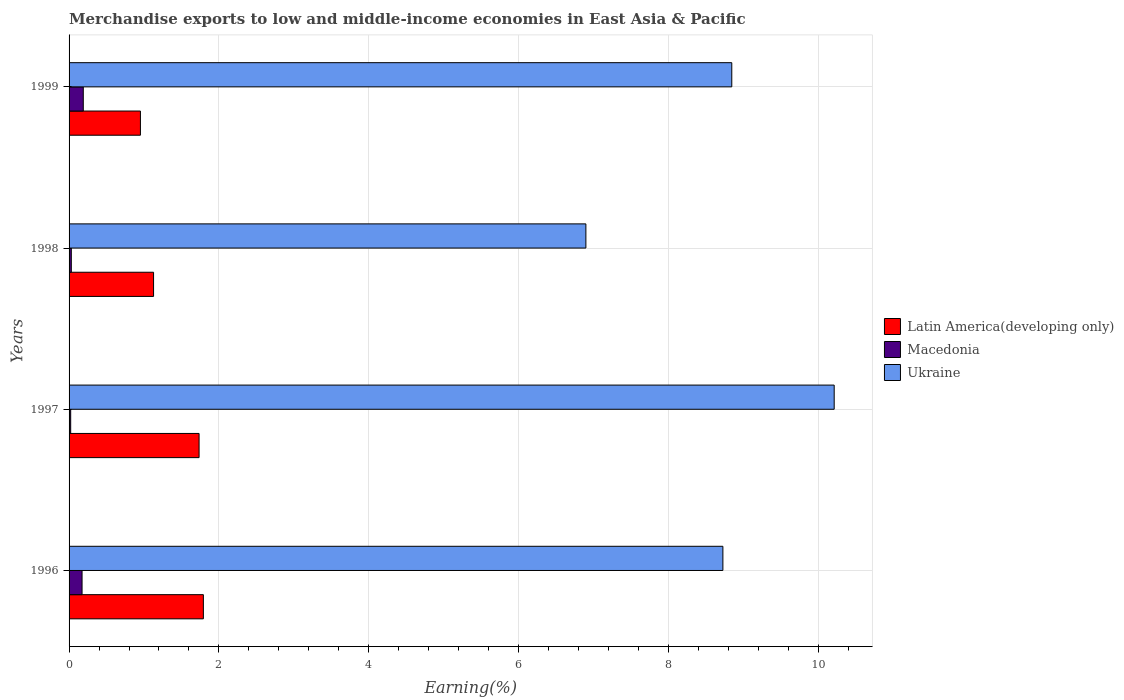Are the number of bars on each tick of the Y-axis equal?
Ensure brevity in your answer.  Yes. How many bars are there on the 4th tick from the top?
Ensure brevity in your answer.  3. How many bars are there on the 1st tick from the bottom?
Provide a succinct answer. 3. In how many cases, is the number of bars for a given year not equal to the number of legend labels?
Provide a short and direct response. 0. What is the percentage of amount earned from merchandise exports in Latin America(developing only) in 1996?
Provide a short and direct response. 1.79. Across all years, what is the maximum percentage of amount earned from merchandise exports in Latin America(developing only)?
Your answer should be very brief. 1.79. Across all years, what is the minimum percentage of amount earned from merchandise exports in Ukraine?
Provide a short and direct response. 6.9. What is the total percentage of amount earned from merchandise exports in Ukraine in the graph?
Keep it short and to the point. 34.69. What is the difference between the percentage of amount earned from merchandise exports in Macedonia in 1997 and that in 1998?
Keep it short and to the point. -0.01. What is the difference between the percentage of amount earned from merchandise exports in Macedonia in 1997 and the percentage of amount earned from merchandise exports in Ukraine in 1999?
Ensure brevity in your answer.  -8.82. What is the average percentage of amount earned from merchandise exports in Latin America(developing only) per year?
Your response must be concise. 1.4. In the year 1997, what is the difference between the percentage of amount earned from merchandise exports in Ukraine and percentage of amount earned from merchandise exports in Latin America(developing only)?
Your response must be concise. 8.48. What is the ratio of the percentage of amount earned from merchandise exports in Latin America(developing only) in 1996 to that in 1997?
Ensure brevity in your answer.  1.03. Is the percentage of amount earned from merchandise exports in Macedonia in 1996 less than that in 1997?
Offer a very short reply. No. What is the difference between the highest and the second highest percentage of amount earned from merchandise exports in Ukraine?
Provide a short and direct response. 1.37. What is the difference between the highest and the lowest percentage of amount earned from merchandise exports in Macedonia?
Make the answer very short. 0.17. Is the sum of the percentage of amount earned from merchandise exports in Macedonia in 1997 and 1998 greater than the maximum percentage of amount earned from merchandise exports in Ukraine across all years?
Keep it short and to the point. No. What does the 2nd bar from the top in 1998 represents?
Provide a succinct answer. Macedonia. What does the 1st bar from the bottom in 1998 represents?
Your answer should be very brief. Latin America(developing only). Is it the case that in every year, the sum of the percentage of amount earned from merchandise exports in Macedonia and percentage of amount earned from merchandise exports in Latin America(developing only) is greater than the percentage of amount earned from merchandise exports in Ukraine?
Ensure brevity in your answer.  No. How many bars are there?
Give a very brief answer. 12. What is the difference between two consecutive major ticks on the X-axis?
Your answer should be very brief. 2. Are the values on the major ticks of X-axis written in scientific E-notation?
Offer a terse response. No. Does the graph contain any zero values?
Provide a succinct answer. No. Where does the legend appear in the graph?
Offer a terse response. Center right. How many legend labels are there?
Provide a succinct answer. 3. How are the legend labels stacked?
Make the answer very short. Vertical. What is the title of the graph?
Provide a short and direct response. Merchandise exports to low and middle-income economies in East Asia & Pacific. Does "Togo" appear as one of the legend labels in the graph?
Provide a short and direct response. No. What is the label or title of the X-axis?
Your response must be concise. Earning(%). What is the Earning(%) in Latin America(developing only) in 1996?
Give a very brief answer. 1.79. What is the Earning(%) of Macedonia in 1996?
Offer a terse response. 0.17. What is the Earning(%) in Ukraine in 1996?
Your response must be concise. 8.73. What is the Earning(%) in Latin America(developing only) in 1997?
Keep it short and to the point. 1.74. What is the Earning(%) of Macedonia in 1997?
Provide a short and direct response. 0.02. What is the Earning(%) of Ukraine in 1997?
Keep it short and to the point. 10.21. What is the Earning(%) of Latin America(developing only) in 1998?
Give a very brief answer. 1.13. What is the Earning(%) of Macedonia in 1998?
Ensure brevity in your answer.  0.03. What is the Earning(%) in Ukraine in 1998?
Your response must be concise. 6.9. What is the Earning(%) of Latin America(developing only) in 1999?
Offer a very short reply. 0.95. What is the Earning(%) of Macedonia in 1999?
Give a very brief answer. 0.19. What is the Earning(%) of Ukraine in 1999?
Make the answer very short. 8.85. Across all years, what is the maximum Earning(%) in Latin America(developing only)?
Provide a succinct answer. 1.79. Across all years, what is the maximum Earning(%) of Macedonia?
Ensure brevity in your answer.  0.19. Across all years, what is the maximum Earning(%) in Ukraine?
Provide a short and direct response. 10.21. Across all years, what is the minimum Earning(%) in Latin America(developing only)?
Offer a very short reply. 0.95. Across all years, what is the minimum Earning(%) of Macedonia?
Ensure brevity in your answer.  0.02. Across all years, what is the minimum Earning(%) of Ukraine?
Make the answer very short. 6.9. What is the total Earning(%) in Latin America(developing only) in the graph?
Give a very brief answer. 5.61. What is the total Earning(%) of Macedonia in the graph?
Your answer should be compact. 0.41. What is the total Earning(%) of Ukraine in the graph?
Provide a short and direct response. 34.69. What is the difference between the Earning(%) of Latin America(developing only) in 1996 and that in 1997?
Your response must be concise. 0.06. What is the difference between the Earning(%) of Macedonia in 1996 and that in 1997?
Your answer should be very brief. 0.15. What is the difference between the Earning(%) in Ukraine in 1996 and that in 1997?
Provide a succinct answer. -1.49. What is the difference between the Earning(%) of Latin America(developing only) in 1996 and that in 1998?
Provide a succinct answer. 0.66. What is the difference between the Earning(%) in Macedonia in 1996 and that in 1998?
Give a very brief answer. 0.14. What is the difference between the Earning(%) of Ukraine in 1996 and that in 1998?
Make the answer very short. 1.83. What is the difference between the Earning(%) of Latin America(developing only) in 1996 and that in 1999?
Your answer should be very brief. 0.84. What is the difference between the Earning(%) of Macedonia in 1996 and that in 1999?
Provide a short and direct response. -0.02. What is the difference between the Earning(%) of Ukraine in 1996 and that in 1999?
Your answer should be compact. -0.12. What is the difference between the Earning(%) in Latin America(developing only) in 1997 and that in 1998?
Offer a terse response. 0.61. What is the difference between the Earning(%) in Macedonia in 1997 and that in 1998?
Provide a succinct answer. -0.01. What is the difference between the Earning(%) in Ukraine in 1997 and that in 1998?
Provide a short and direct response. 3.31. What is the difference between the Earning(%) of Latin America(developing only) in 1997 and that in 1999?
Provide a short and direct response. 0.78. What is the difference between the Earning(%) of Macedonia in 1997 and that in 1999?
Provide a short and direct response. -0.17. What is the difference between the Earning(%) of Ukraine in 1997 and that in 1999?
Provide a succinct answer. 1.37. What is the difference between the Earning(%) of Latin America(developing only) in 1998 and that in 1999?
Your response must be concise. 0.18. What is the difference between the Earning(%) in Macedonia in 1998 and that in 1999?
Give a very brief answer. -0.16. What is the difference between the Earning(%) in Ukraine in 1998 and that in 1999?
Your answer should be very brief. -1.95. What is the difference between the Earning(%) of Latin America(developing only) in 1996 and the Earning(%) of Macedonia in 1997?
Your response must be concise. 1.77. What is the difference between the Earning(%) of Latin America(developing only) in 1996 and the Earning(%) of Ukraine in 1997?
Your answer should be compact. -8.42. What is the difference between the Earning(%) in Macedonia in 1996 and the Earning(%) in Ukraine in 1997?
Your response must be concise. -10.04. What is the difference between the Earning(%) in Latin America(developing only) in 1996 and the Earning(%) in Macedonia in 1998?
Offer a terse response. 1.76. What is the difference between the Earning(%) in Latin America(developing only) in 1996 and the Earning(%) in Ukraine in 1998?
Provide a succinct answer. -5.11. What is the difference between the Earning(%) of Macedonia in 1996 and the Earning(%) of Ukraine in 1998?
Offer a terse response. -6.73. What is the difference between the Earning(%) of Latin America(developing only) in 1996 and the Earning(%) of Macedonia in 1999?
Offer a very short reply. 1.6. What is the difference between the Earning(%) of Latin America(developing only) in 1996 and the Earning(%) of Ukraine in 1999?
Ensure brevity in your answer.  -7.05. What is the difference between the Earning(%) in Macedonia in 1996 and the Earning(%) in Ukraine in 1999?
Offer a terse response. -8.67. What is the difference between the Earning(%) of Latin America(developing only) in 1997 and the Earning(%) of Macedonia in 1998?
Give a very brief answer. 1.71. What is the difference between the Earning(%) in Latin America(developing only) in 1997 and the Earning(%) in Ukraine in 1998?
Give a very brief answer. -5.16. What is the difference between the Earning(%) of Macedonia in 1997 and the Earning(%) of Ukraine in 1998?
Keep it short and to the point. -6.88. What is the difference between the Earning(%) in Latin America(developing only) in 1997 and the Earning(%) in Macedonia in 1999?
Ensure brevity in your answer.  1.55. What is the difference between the Earning(%) in Latin America(developing only) in 1997 and the Earning(%) in Ukraine in 1999?
Your response must be concise. -7.11. What is the difference between the Earning(%) of Macedonia in 1997 and the Earning(%) of Ukraine in 1999?
Keep it short and to the point. -8.82. What is the difference between the Earning(%) in Latin America(developing only) in 1998 and the Earning(%) in Macedonia in 1999?
Provide a succinct answer. 0.94. What is the difference between the Earning(%) in Latin America(developing only) in 1998 and the Earning(%) in Ukraine in 1999?
Provide a succinct answer. -7.72. What is the difference between the Earning(%) in Macedonia in 1998 and the Earning(%) in Ukraine in 1999?
Offer a terse response. -8.82. What is the average Earning(%) of Latin America(developing only) per year?
Your answer should be compact. 1.4. What is the average Earning(%) in Macedonia per year?
Keep it short and to the point. 0.1. What is the average Earning(%) in Ukraine per year?
Provide a succinct answer. 8.67. In the year 1996, what is the difference between the Earning(%) of Latin America(developing only) and Earning(%) of Macedonia?
Provide a succinct answer. 1.62. In the year 1996, what is the difference between the Earning(%) in Latin America(developing only) and Earning(%) in Ukraine?
Your answer should be very brief. -6.93. In the year 1996, what is the difference between the Earning(%) of Macedonia and Earning(%) of Ukraine?
Make the answer very short. -8.55. In the year 1997, what is the difference between the Earning(%) of Latin America(developing only) and Earning(%) of Macedonia?
Your answer should be very brief. 1.71. In the year 1997, what is the difference between the Earning(%) of Latin America(developing only) and Earning(%) of Ukraine?
Ensure brevity in your answer.  -8.48. In the year 1997, what is the difference between the Earning(%) in Macedonia and Earning(%) in Ukraine?
Offer a very short reply. -10.19. In the year 1998, what is the difference between the Earning(%) in Latin America(developing only) and Earning(%) in Macedonia?
Your response must be concise. 1.1. In the year 1998, what is the difference between the Earning(%) in Latin America(developing only) and Earning(%) in Ukraine?
Provide a succinct answer. -5.77. In the year 1998, what is the difference between the Earning(%) of Macedonia and Earning(%) of Ukraine?
Provide a short and direct response. -6.87. In the year 1999, what is the difference between the Earning(%) of Latin America(developing only) and Earning(%) of Macedonia?
Your response must be concise. 0.76. In the year 1999, what is the difference between the Earning(%) in Latin America(developing only) and Earning(%) in Ukraine?
Keep it short and to the point. -7.89. In the year 1999, what is the difference between the Earning(%) in Macedonia and Earning(%) in Ukraine?
Offer a terse response. -8.66. What is the ratio of the Earning(%) of Latin America(developing only) in 1996 to that in 1997?
Your answer should be compact. 1.03. What is the ratio of the Earning(%) of Macedonia in 1996 to that in 1997?
Provide a short and direct response. 8.01. What is the ratio of the Earning(%) of Ukraine in 1996 to that in 1997?
Provide a short and direct response. 0.85. What is the ratio of the Earning(%) of Latin America(developing only) in 1996 to that in 1998?
Provide a short and direct response. 1.59. What is the ratio of the Earning(%) in Macedonia in 1996 to that in 1998?
Keep it short and to the point. 5.8. What is the ratio of the Earning(%) of Ukraine in 1996 to that in 1998?
Ensure brevity in your answer.  1.27. What is the ratio of the Earning(%) in Latin America(developing only) in 1996 to that in 1999?
Your answer should be very brief. 1.88. What is the ratio of the Earning(%) of Macedonia in 1996 to that in 1999?
Ensure brevity in your answer.  0.91. What is the ratio of the Earning(%) of Ukraine in 1996 to that in 1999?
Make the answer very short. 0.99. What is the ratio of the Earning(%) of Latin America(developing only) in 1997 to that in 1998?
Your answer should be compact. 1.54. What is the ratio of the Earning(%) of Macedonia in 1997 to that in 1998?
Ensure brevity in your answer.  0.72. What is the ratio of the Earning(%) of Ukraine in 1997 to that in 1998?
Give a very brief answer. 1.48. What is the ratio of the Earning(%) of Latin America(developing only) in 1997 to that in 1999?
Give a very brief answer. 1.82. What is the ratio of the Earning(%) in Macedonia in 1997 to that in 1999?
Make the answer very short. 0.11. What is the ratio of the Earning(%) in Ukraine in 1997 to that in 1999?
Your response must be concise. 1.15. What is the ratio of the Earning(%) in Latin America(developing only) in 1998 to that in 1999?
Your answer should be very brief. 1.18. What is the ratio of the Earning(%) in Macedonia in 1998 to that in 1999?
Provide a succinct answer. 0.16. What is the ratio of the Earning(%) of Ukraine in 1998 to that in 1999?
Provide a succinct answer. 0.78. What is the difference between the highest and the second highest Earning(%) of Latin America(developing only)?
Make the answer very short. 0.06. What is the difference between the highest and the second highest Earning(%) of Macedonia?
Your response must be concise. 0.02. What is the difference between the highest and the second highest Earning(%) of Ukraine?
Provide a short and direct response. 1.37. What is the difference between the highest and the lowest Earning(%) of Latin America(developing only)?
Your response must be concise. 0.84. What is the difference between the highest and the lowest Earning(%) of Macedonia?
Your answer should be very brief. 0.17. What is the difference between the highest and the lowest Earning(%) in Ukraine?
Offer a very short reply. 3.31. 